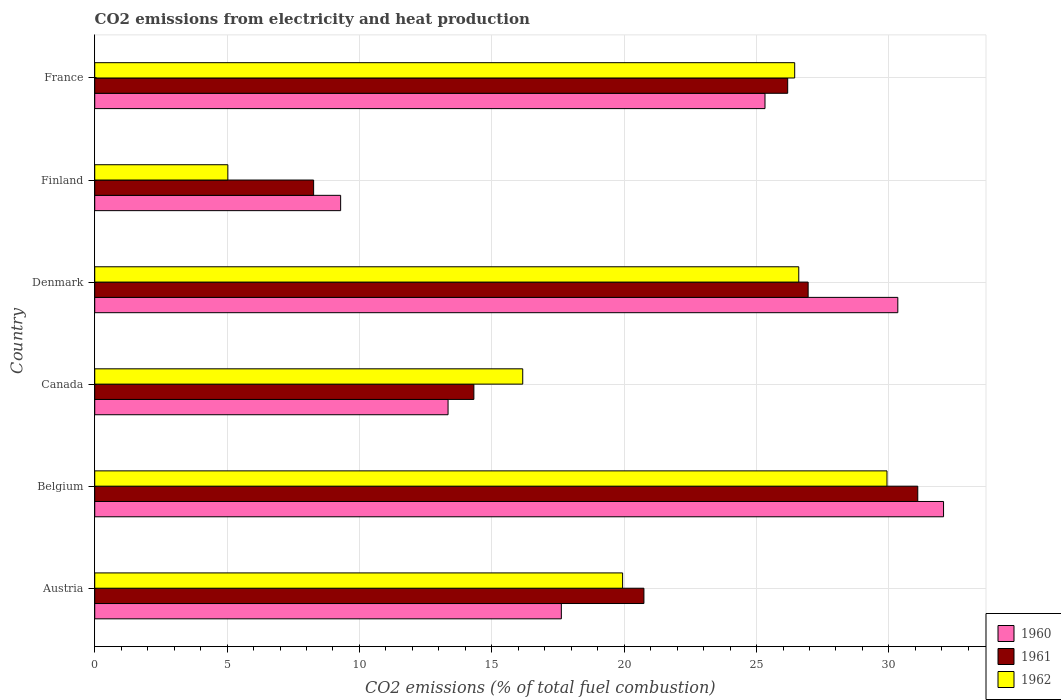How many different coloured bars are there?
Offer a very short reply. 3. What is the label of the 6th group of bars from the top?
Give a very brief answer. Austria. In how many cases, is the number of bars for a given country not equal to the number of legend labels?
Give a very brief answer. 0. What is the amount of CO2 emitted in 1961 in France?
Ensure brevity in your answer.  26.18. Across all countries, what is the maximum amount of CO2 emitted in 1961?
Provide a succinct answer. 31.09. Across all countries, what is the minimum amount of CO2 emitted in 1960?
Your answer should be compact. 9.29. In which country was the amount of CO2 emitted in 1960 maximum?
Give a very brief answer. Belgium. In which country was the amount of CO2 emitted in 1961 minimum?
Your answer should be very brief. Finland. What is the total amount of CO2 emitted in 1960 in the graph?
Offer a terse response. 127.98. What is the difference between the amount of CO2 emitted in 1962 in Denmark and that in Finland?
Keep it short and to the point. 21.57. What is the difference between the amount of CO2 emitted in 1961 in Finland and the amount of CO2 emitted in 1962 in Austria?
Offer a very short reply. -11.67. What is the average amount of CO2 emitted in 1961 per country?
Give a very brief answer. 21.26. What is the difference between the amount of CO2 emitted in 1962 and amount of CO2 emitted in 1960 in Canada?
Your response must be concise. 2.82. What is the ratio of the amount of CO2 emitted in 1960 in Canada to that in Finland?
Your answer should be very brief. 1.44. Is the amount of CO2 emitted in 1960 in Austria less than that in Canada?
Your answer should be compact. No. What is the difference between the highest and the second highest amount of CO2 emitted in 1960?
Make the answer very short. 1.73. What is the difference between the highest and the lowest amount of CO2 emitted in 1960?
Provide a succinct answer. 22.77. Is the sum of the amount of CO2 emitted in 1962 in Belgium and Canada greater than the maximum amount of CO2 emitted in 1961 across all countries?
Provide a succinct answer. Yes. What does the 3rd bar from the top in France represents?
Ensure brevity in your answer.  1960. What does the 1st bar from the bottom in Denmark represents?
Ensure brevity in your answer.  1960. Is it the case that in every country, the sum of the amount of CO2 emitted in 1962 and amount of CO2 emitted in 1961 is greater than the amount of CO2 emitted in 1960?
Offer a very short reply. Yes. How many bars are there?
Give a very brief answer. 18. Are all the bars in the graph horizontal?
Provide a short and direct response. Yes. What is the difference between two consecutive major ticks on the X-axis?
Ensure brevity in your answer.  5. Does the graph contain any zero values?
Keep it short and to the point. No. Does the graph contain grids?
Your answer should be very brief. Yes. What is the title of the graph?
Your response must be concise. CO2 emissions from electricity and heat production. Does "1971" appear as one of the legend labels in the graph?
Provide a succinct answer. No. What is the label or title of the X-axis?
Offer a very short reply. CO2 emissions (% of total fuel combustion). What is the label or title of the Y-axis?
Ensure brevity in your answer.  Country. What is the CO2 emissions (% of total fuel combustion) of 1960 in Austria?
Your answer should be compact. 17.63. What is the CO2 emissions (% of total fuel combustion) in 1961 in Austria?
Keep it short and to the point. 20.75. What is the CO2 emissions (% of total fuel combustion) in 1962 in Austria?
Provide a succinct answer. 19.94. What is the CO2 emissions (% of total fuel combustion) of 1960 in Belgium?
Give a very brief answer. 32.06. What is the CO2 emissions (% of total fuel combustion) of 1961 in Belgium?
Offer a terse response. 31.09. What is the CO2 emissions (% of total fuel combustion) in 1962 in Belgium?
Ensure brevity in your answer.  29.93. What is the CO2 emissions (% of total fuel combustion) in 1960 in Canada?
Ensure brevity in your answer.  13.35. What is the CO2 emissions (% of total fuel combustion) in 1961 in Canada?
Offer a very short reply. 14.32. What is the CO2 emissions (% of total fuel combustion) of 1962 in Canada?
Ensure brevity in your answer.  16.17. What is the CO2 emissions (% of total fuel combustion) in 1960 in Denmark?
Your response must be concise. 30.34. What is the CO2 emissions (% of total fuel combustion) in 1961 in Denmark?
Your answer should be very brief. 26.95. What is the CO2 emissions (% of total fuel combustion) in 1962 in Denmark?
Provide a short and direct response. 26.59. What is the CO2 emissions (% of total fuel combustion) of 1960 in Finland?
Offer a terse response. 9.29. What is the CO2 emissions (% of total fuel combustion) in 1961 in Finland?
Your response must be concise. 8.27. What is the CO2 emissions (% of total fuel combustion) in 1962 in Finland?
Ensure brevity in your answer.  5.03. What is the CO2 emissions (% of total fuel combustion) in 1960 in France?
Your answer should be compact. 25.32. What is the CO2 emissions (% of total fuel combustion) of 1961 in France?
Offer a terse response. 26.18. What is the CO2 emissions (% of total fuel combustion) of 1962 in France?
Keep it short and to the point. 26.44. Across all countries, what is the maximum CO2 emissions (% of total fuel combustion) in 1960?
Provide a short and direct response. 32.06. Across all countries, what is the maximum CO2 emissions (% of total fuel combustion) in 1961?
Offer a terse response. 31.09. Across all countries, what is the maximum CO2 emissions (% of total fuel combustion) in 1962?
Ensure brevity in your answer.  29.93. Across all countries, what is the minimum CO2 emissions (% of total fuel combustion) in 1960?
Offer a terse response. 9.29. Across all countries, what is the minimum CO2 emissions (% of total fuel combustion) of 1961?
Keep it short and to the point. 8.27. Across all countries, what is the minimum CO2 emissions (% of total fuel combustion) in 1962?
Make the answer very short. 5.03. What is the total CO2 emissions (% of total fuel combustion) in 1960 in the graph?
Your answer should be compact. 127.98. What is the total CO2 emissions (% of total fuel combustion) of 1961 in the graph?
Your answer should be very brief. 127.55. What is the total CO2 emissions (% of total fuel combustion) of 1962 in the graph?
Your answer should be compact. 124.1. What is the difference between the CO2 emissions (% of total fuel combustion) of 1960 in Austria and that in Belgium?
Your response must be concise. -14.44. What is the difference between the CO2 emissions (% of total fuel combustion) in 1961 in Austria and that in Belgium?
Your answer should be very brief. -10.34. What is the difference between the CO2 emissions (% of total fuel combustion) of 1962 in Austria and that in Belgium?
Keep it short and to the point. -9.99. What is the difference between the CO2 emissions (% of total fuel combustion) of 1960 in Austria and that in Canada?
Your response must be concise. 4.28. What is the difference between the CO2 emissions (% of total fuel combustion) of 1961 in Austria and that in Canada?
Make the answer very short. 6.42. What is the difference between the CO2 emissions (% of total fuel combustion) in 1962 in Austria and that in Canada?
Offer a very short reply. 3.77. What is the difference between the CO2 emissions (% of total fuel combustion) of 1960 in Austria and that in Denmark?
Keep it short and to the point. -12.71. What is the difference between the CO2 emissions (% of total fuel combustion) in 1961 in Austria and that in Denmark?
Your answer should be compact. -6.2. What is the difference between the CO2 emissions (% of total fuel combustion) in 1962 in Austria and that in Denmark?
Give a very brief answer. -6.65. What is the difference between the CO2 emissions (% of total fuel combustion) of 1960 in Austria and that in Finland?
Offer a terse response. 8.34. What is the difference between the CO2 emissions (% of total fuel combustion) in 1961 in Austria and that in Finland?
Ensure brevity in your answer.  12.48. What is the difference between the CO2 emissions (% of total fuel combustion) in 1962 in Austria and that in Finland?
Your answer should be very brief. 14.91. What is the difference between the CO2 emissions (% of total fuel combustion) in 1960 in Austria and that in France?
Give a very brief answer. -7.69. What is the difference between the CO2 emissions (% of total fuel combustion) in 1961 in Austria and that in France?
Keep it short and to the point. -5.43. What is the difference between the CO2 emissions (% of total fuel combustion) of 1962 in Austria and that in France?
Offer a very short reply. -6.5. What is the difference between the CO2 emissions (% of total fuel combustion) in 1960 in Belgium and that in Canada?
Keep it short and to the point. 18.72. What is the difference between the CO2 emissions (% of total fuel combustion) in 1961 in Belgium and that in Canada?
Provide a short and direct response. 16.77. What is the difference between the CO2 emissions (% of total fuel combustion) of 1962 in Belgium and that in Canada?
Your response must be concise. 13.76. What is the difference between the CO2 emissions (% of total fuel combustion) in 1960 in Belgium and that in Denmark?
Your answer should be compact. 1.73. What is the difference between the CO2 emissions (% of total fuel combustion) in 1961 in Belgium and that in Denmark?
Keep it short and to the point. 4.14. What is the difference between the CO2 emissions (% of total fuel combustion) of 1962 in Belgium and that in Denmark?
Your answer should be compact. 3.33. What is the difference between the CO2 emissions (% of total fuel combustion) of 1960 in Belgium and that in Finland?
Your answer should be compact. 22.77. What is the difference between the CO2 emissions (% of total fuel combustion) of 1961 in Belgium and that in Finland?
Make the answer very short. 22.82. What is the difference between the CO2 emissions (% of total fuel combustion) in 1962 in Belgium and that in Finland?
Provide a short and direct response. 24.9. What is the difference between the CO2 emissions (% of total fuel combustion) in 1960 in Belgium and that in France?
Offer a terse response. 6.74. What is the difference between the CO2 emissions (% of total fuel combustion) of 1961 in Belgium and that in France?
Offer a very short reply. 4.91. What is the difference between the CO2 emissions (% of total fuel combustion) in 1962 in Belgium and that in France?
Offer a very short reply. 3.49. What is the difference between the CO2 emissions (% of total fuel combustion) of 1960 in Canada and that in Denmark?
Give a very brief answer. -16.99. What is the difference between the CO2 emissions (% of total fuel combustion) of 1961 in Canada and that in Denmark?
Make the answer very short. -12.63. What is the difference between the CO2 emissions (% of total fuel combustion) in 1962 in Canada and that in Denmark?
Keep it short and to the point. -10.43. What is the difference between the CO2 emissions (% of total fuel combustion) in 1960 in Canada and that in Finland?
Make the answer very short. 4.06. What is the difference between the CO2 emissions (% of total fuel combustion) of 1961 in Canada and that in Finland?
Provide a succinct answer. 6.05. What is the difference between the CO2 emissions (% of total fuel combustion) in 1962 in Canada and that in Finland?
Offer a terse response. 11.14. What is the difference between the CO2 emissions (% of total fuel combustion) in 1960 in Canada and that in France?
Provide a short and direct response. -11.97. What is the difference between the CO2 emissions (% of total fuel combustion) of 1961 in Canada and that in France?
Offer a very short reply. -11.85. What is the difference between the CO2 emissions (% of total fuel combustion) of 1962 in Canada and that in France?
Offer a very short reply. -10.27. What is the difference between the CO2 emissions (% of total fuel combustion) in 1960 in Denmark and that in Finland?
Provide a short and direct response. 21.05. What is the difference between the CO2 emissions (% of total fuel combustion) in 1961 in Denmark and that in Finland?
Provide a succinct answer. 18.68. What is the difference between the CO2 emissions (% of total fuel combustion) of 1962 in Denmark and that in Finland?
Your response must be concise. 21.57. What is the difference between the CO2 emissions (% of total fuel combustion) in 1960 in Denmark and that in France?
Offer a very short reply. 5.02. What is the difference between the CO2 emissions (% of total fuel combustion) in 1961 in Denmark and that in France?
Keep it short and to the point. 0.77. What is the difference between the CO2 emissions (% of total fuel combustion) of 1962 in Denmark and that in France?
Keep it short and to the point. 0.15. What is the difference between the CO2 emissions (% of total fuel combustion) of 1960 in Finland and that in France?
Ensure brevity in your answer.  -16.03. What is the difference between the CO2 emissions (% of total fuel combustion) of 1961 in Finland and that in France?
Offer a very short reply. -17.91. What is the difference between the CO2 emissions (% of total fuel combustion) in 1962 in Finland and that in France?
Ensure brevity in your answer.  -21.41. What is the difference between the CO2 emissions (% of total fuel combustion) of 1960 in Austria and the CO2 emissions (% of total fuel combustion) of 1961 in Belgium?
Keep it short and to the point. -13.46. What is the difference between the CO2 emissions (% of total fuel combustion) of 1960 in Austria and the CO2 emissions (% of total fuel combustion) of 1962 in Belgium?
Provide a short and direct response. -12.3. What is the difference between the CO2 emissions (% of total fuel combustion) of 1961 in Austria and the CO2 emissions (% of total fuel combustion) of 1962 in Belgium?
Your response must be concise. -9.18. What is the difference between the CO2 emissions (% of total fuel combustion) of 1960 in Austria and the CO2 emissions (% of total fuel combustion) of 1961 in Canada?
Give a very brief answer. 3.3. What is the difference between the CO2 emissions (% of total fuel combustion) of 1960 in Austria and the CO2 emissions (% of total fuel combustion) of 1962 in Canada?
Your answer should be very brief. 1.46. What is the difference between the CO2 emissions (% of total fuel combustion) in 1961 in Austria and the CO2 emissions (% of total fuel combustion) in 1962 in Canada?
Give a very brief answer. 4.58. What is the difference between the CO2 emissions (% of total fuel combustion) of 1960 in Austria and the CO2 emissions (% of total fuel combustion) of 1961 in Denmark?
Your answer should be compact. -9.32. What is the difference between the CO2 emissions (% of total fuel combustion) of 1960 in Austria and the CO2 emissions (% of total fuel combustion) of 1962 in Denmark?
Your answer should be compact. -8.97. What is the difference between the CO2 emissions (% of total fuel combustion) in 1961 in Austria and the CO2 emissions (% of total fuel combustion) in 1962 in Denmark?
Make the answer very short. -5.85. What is the difference between the CO2 emissions (% of total fuel combustion) of 1960 in Austria and the CO2 emissions (% of total fuel combustion) of 1961 in Finland?
Offer a terse response. 9.36. What is the difference between the CO2 emissions (% of total fuel combustion) in 1960 in Austria and the CO2 emissions (% of total fuel combustion) in 1962 in Finland?
Offer a very short reply. 12.6. What is the difference between the CO2 emissions (% of total fuel combustion) in 1961 in Austria and the CO2 emissions (% of total fuel combustion) in 1962 in Finland?
Your response must be concise. 15.72. What is the difference between the CO2 emissions (% of total fuel combustion) in 1960 in Austria and the CO2 emissions (% of total fuel combustion) in 1961 in France?
Offer a very short reply. -8.55. What is the difference between the CO2 emissions (% of total fuel combustion) of 1960 in Austria and the CO2 emissions (% of total fuel combustion) of 1962 in France?
Your answer should be very brief. -8.81. What is the difference between the CO2 emissions (% of total fuel combustion) in 1961 in Austria and the CO2 emissions (% of total fuel combustion) in 1962 in France?
Make the answer very short. -5.69. What is the difference between the CO2 emissions (% of total fuel combustion) of 1960 in Belgium and the CO2 emissions (% of total fuel combustion) of 1961 in Canada?
Provide a succinct answer. 17.74. What is the difference between the CO2 emissions (% of total fuel combustion) in 1960 in Belgium and the CO2 emissions (% of total fuel combustion) in 1962 in Canada?
Provide a succinct answer. 15.9. What is the difference between the CO2 emissions (% of total fuel combustion) of 1961 in Belgium and the CO2 emissions (% of total fuel combustion) of 1962 in Canada?
Offer a terse response. 14.92. What is the difference between the CO2 emissions (% of total fuel combustion) in 1960 in Belgium and the CO2 emissions (% of total fuel combustion) in 1961 in Denmark?
Make the answer very short. 5.11. What is the difference between the CO2 emissions (% of total fuel combustion) of 1960 in Belgium and the CO2 emissions (% of total fuel combustion) of 1962 in Denmark?
Your response must be concise. 5.47. What is the difference between the CO2 emissions (% of total fuel combustion) of 1961 in Belgium and the CO2 emissions (% of total fuel combustion) of 1962 in Denmark?
Keep it short and to the point. 4.5. What is the difference between the CO2 emissions (% of total fuel combustion) in 1960 in Belgium and the CO2 emissions (% of total fuel combustion) in 1961 in Finland?
Keep it short and to the point. 23.79. What is the difference between the CO2 emissions (% of total fuel combustion) in 1960 in Belgium and the CO2 emissions (% of total fuel combustion) in 1962 in Finland?
Your answer should be compact. 27.04. What is the difference between the CO2 emissions (% of total fuel combustion) in 1961 in Belgium and the CO2 emissions (% of total fuel combustion) in 1962 in Finland?
Your answer should be compact. 26.06. What is the difference between the CO2 emissions (% of total fuel combustion) in 1960 in Belgium and the CO2 emissions (% of total fuel combustion) in 1961 in France?
Offer a very short reply. 5.89. What is the difference between the CO2 emissions (% of total fuel combustion) in 1960 in Belgium and the CO2 emissions (% of total fuel combustion) in 1962 in France?
Offer a terse response. 5.62. What is the difference between the CO2 emissions (% of total fuel combustion) of 1961 in Belgium and the CO2 emissions (% of total fuel combustion) of 1962 in France?
Offer a terse response. 4.65. What is the difference between the CO2 emissions (% of total fuel combustion) of 1960 in Canada and the CO2 emissions (% of total fuel combustion) of 1961 in Denmark?
Provide a succinct answer. -13.6. What is the difference between the CO2 emissions (% of total fuel combustion) in 1960 in Canada and the CO2 emissions (% of total fuel combustion) in 1962 in Denmark?
Offer a terse response. -13.25. What is the difference between the CO2 emissions (% of total fuel combustion) in 1961 in Canada and the CO2 emissions (% of total fuel combustion) in 1962 in Denmark?
Offer a very short reply. -12.27. What is the difference between the CO2 emissions (% of total fuel combustion) in 1960 in Canada and the CO2 emissions (% of total fuel combustion) in 1961 in Finland?
Offer a terse response. 5.08. What is the difference between the CO2 emissions (% of total fuel combustion) of 1960 in Canada and the CO2 emissions (% of total fuel combustion) of 1962 in Finland?
Your answer should be very brief. 8.32. What is the difference between the CO2 emissions (% of total fuel combustion) in 1961 in Canada and the CO2 emissions (% of total fuel combustion) in 1962 in Finland?
Your response must be concise. 9.29. What is the difference between the CO2 emissions (% of total fuel combustion) in 1960 in Canada and the CO2 emissions (% of total fuel combustion) in 1961 in France?
Provide a succinct answer. -12.83. What is the difference between the CO2 emissions (% of total fuel combustion) in 1960 in Canada and the CO2 emissions (% of total fuel combustion) in 1962 in France?
Keep it short and to the point. -13.09. What is the difference between the CO2 emissions (% of total fuel combustion) in 1961 in Canada and the CO2 emissions (% of total fuel combustion) in 1962 in France?
Offer a very short reply. -12.12. What is the difference between the CO2 emissions (% of total fuel combustion) in 1960 in Denmark and the CO2 emissions (% of total fuel combustion) in 1961 in Finland?
Make the answer very short. 22.07. What is the difference between the CO2 emissions (% of total fuel combustion) in 1960 in Denmark and the CO2 emissions (% of total fuel combustion) in 1962 in Finland?
Your answer should be very brief. 25.31. What is the difference between the CO2 emissions (% of total fuel combustion) in 1961 in Denmark and the CO2 emissions (% of total fuel combustion) in 1962 in Finland?
Ensure brevity in your answer.  21.92. What is the difference between the CO2 emissions (% of total fuel combustion) in 1960 in Denmark and the CO2 emissions (% of total fuel combustion) in 1961 in France?
Offer a terse response. 4.16. What is the difference between the CO2 emissions (% of total fuel combustion) in 1960 in Denmark and the CO2 emissions (% of total fuel combustion) in 1962 in France?
Provide a succinct answer. 3.9. What is the difference between the CO2 emissions (% of total fuel combustion) of 1961 in Denmark and the CO2 emissions (% of total fuel combustion) of 1962 in France?
Your answer should be compact. 0.51. What is the difference between the CO2 emissions (% of total fuel combustion) in 1960 in Finland and the CO2 emissions (% of total fuel combustion) in 1961 in France?
Provide a short and direct response. -16.89. What is the difference between the CO2 emissions (% of total fuel combustion) of 1960 in Finland and the CO2 emissions (% of total fuel combustion) of 1962 in France?
Ensure brevity in your answer.  -17.15. What is the difference between the CO2 emissions (% of total fuel combustion) of 1961 in Finland and the CO2 emissions (% of total fuel combustion) of 1962 in France?
Give a very brief answer. -18.17. What is the average CO2 emissions (% of total fuel combustion) of 1960 per country?
Offer a very short reply. 21.33. What is the average CO2 emissions (% of total fuel combustion) in 1961 per country?
Ensure brevity in your answer.  21.26. What is the average CO2 emissions (% of total fuel combustion) in 1962 per country?
Offer a terse response. 20.68. What is the difference between the CO2 emissions (% of total fuel combustion) of 1960 and CO2 emissions (% of total fuel combustion) of 1961 in Austria?
Your answer should be compact. -3.12. What is the difference between the CO2 emissions (% of total fuel combustion) in 1960 and CO2 emissions (% of total fuel combustion) in 1962 in Austria?
Make the answer very short. -2.31. What is the difference between the CO2 emissions (% of total fuel combustion) in 1961 and CO2 emissions (% of total fuel combustion) in 1962 in Austria?
Ensure brevity in your answer.  0.81. What is the difference between the CO2 emissions (% of total fuel combustion) of 1960 and CO2 emissions (% of total fuel combustion) of 1962 in Belgium?
Your answer should be compact. 2.14. What is the difference between the CO2 emissions (% of total fuel combustion) of 1961 and CO2 emissions (% of total fuel combustion) of 1962 in Belgium?
Ensure brevity in your answer.  1.16. What is the difference between the CO2 emissions (% of total fuel combustion) in 1960 and CO2 emissions (% of total fuel combustion) in 1961 in Canada?
Offer a very short reply. -0.98. What is the difference between the CO2 emissions (% of total fuel combustion) of 1960 and CO2 emissions (% of total fuel combustion) of 1962 in Canada?
Offer a very short reply. -2.82. What is the difference between the CO2 emissions (% of total fuel combustion) of 1961 and CO2 emissions (% of total fuel combustion) of 1962 in Canada?
Provide a short and direct response. -1.85. What is the difference between the CO2 emissions (% of total fuel combustion) in 1960 and CO2 emissions (% of total fuel combustion) in 1961 in Denmark?
Ensure brevity in your answer.  3.39. What is the difference between the CO2 emissions (% of total fuel combustion) of 1960 and CO2 emissions (% of total fuel combustion) of 1962 in Denmark?
Your response must be concise. 3.74. What is the difference between the CO2 emissions (% of total fuel combustion) in 1961 and CO2 emissions (% of total fuel combustion) in 1962 in Denmark?
Your response must be concise. 0.35. What is the difference between the CO2 emissions (% of total fuel combustion) in 1960 and CO2 emissions (% of total fuel combustion) in 1961 in Finland?
Your answer should be very brief. 1.02. What is the difference between the CO2 emissions (% of total fuel combustion) in 1960 and CO2 emissions (% of total fuel combustion) in 1962 in Finland?
Provide a short and direct response. 4.26. What is the difference between the CO2 emissions (% of total fuel combustion) of 1961 and CO2 emissions (% of total fuel combustion) of 1962 in Finland?
Make the answer very short. 3.24. What is the difference between the CO2 emissions (% of total fuel combustion) in 1960 and CO2 emissions (% of total fuel combustion) in 1961 in France?
Give a very brief answer. -0.86. What is the difference between the CO2 emissions (% of total fuel combustion) in 1960 and CO2 emissions (% of total fuel combustion) in 1962 in France?
Make the answer very short. -1.12. What is the difference between the CO2 emissions (% of total fuel combustion) of 1961 and CO2 emissions (% of total fuel combustion) of 1962 in France?
Give a very brief answer. -0.26. What is the ratio of the CO2 emissions (% of total fuel combustion) of 1960 in Austria to that in Belgium?
Offer a terse response. 0.55. What is the ratio of the CO2 emissions (% of total fuel combustion) in 1961 in Austria to that in Belgium?
Give a very brief answer. 0.67. What is the ratio of the CO2 emissions (% of total fuel combustion) in 1962 in Austria to that in Belgium?
Provide a short and direct response. 0.67. What is the ratio of the CO2 emissions (% of total fuel combustion) of 1960 in Austria to that in Canada?
Provide a succinct answer. 1.32. What is the ratio of the CO2 emissions (% of total fuel combustion) in 1961 in Austria to that in Canada?
Offer a very short reply. 1.45. What is the ratio of the CO2 emissions (% of total fuel combustion) of 1962 in Austria to that in Canada?
Offer a very short reply. 1.23. What is the ratio of the CO2 emissions (% of total fuel combustion) in 1960 in Austria to that in Denmark?
Offer a terse response. 0.58. What is the ratio of the CO2 emissions (% of total fuel combustion) in 1961 in Austria to that in Denmark?
Your answer should be very brief. 0.77. What is the ratio of the CO2 emissions (% of total fuel combustion) of 1962 in Austria to that in Denmark?
Ensure brevity in your answer.  0.75. What is the ratio of the CO2 emissions (% of total fuel combustion) in 1960 in Austria to that in Finland?
Make the answer very short. 1.9. What is the ratio of the CO2 emissions (% of total fuel combustion) of 1961 in Austria to that in Finland?
Keep it short and to the point. 2.51. What is the ratio of the CO2 emissions (% of total fuel combustion) in 1962 in Austria to that in Finland?
Offer a terse response. 3.97. What is the ratio of the CO2 emissions (% of total fuel combustion) of 1960 in Austria to that in France?
Your response must be concise. 0.7. What is the ratio of the CO2 emissions (% of total fuel combustion) of 1961 in Austria to that in France?
Your answer should be compact. 0.79. What is the ratio of the CO2 emissions (% of total fuel combustion) of 1962 in Austria to that in France?
Give a very brief answer. 0.75. What is the ratio of the CO2 emissions (% of total fuel combustion) of 1960 in Belgium to that in Canada?
Provide a short and direct response. 2.4. What is the ratio of the CO2 emissions (% of total fuel combustion) in 1961 in Belgium to that in Canada?
Provide a succinct answer. 2.17. What is the ratio of the CO2 emissions (% of total fuel combustion) of 1962 in Belgium to that in Canada?
Offer a terse response. 1.85. What is the ratio of the CO2 emissions (% of total fuel combustion) of 1960 in Belgium to that in Denmark?
Give a very brief answer. 1.06. What is the ratio of the CO2 emissions (% of total fuel combustion) of 1961 in Belgium to that in Denmark?
Your answer should be compact. 1.15. What is the ratio of the CO2 emissions (% of total fuel combustion) of 1962 in Belgium to that in Denmark?
Offer a very short reply. 1.13. What is the ratio of the CO2 emissions (% of total fuel combustion) of 1960 in Belgium to that in Finland?
Your answer should be very brief. 3.45. What is the ratio of the CO2 emissions (% of total fuel combustion) in 1961 in Belgium to that in Finland?
Provide a succinct answer. 3.76. What is the ratio of the CO2 emissions (% of total fuel combustion) in 1962 in Belgium to that in Finland?
Offer a terse response. 5.95. What is the ratio of the CO2 emissions (% of total fuel combustion) in 1960 in Belgium to that in France?
Keep it short and to the point. 1.27. What is the ratio of the CO2 emissions (% of total fuel combustion) in 1961 in Belgium to that in France?
Your answer should be very brief. 1.19. What is the ratio of the CO2 emissions (% of total fuel combustion) in 1962 in Belgium to that in France?
Your answer should be compact. 1.13. What is the ratio of the CO2 emissions (% of total fuel combustion) of 1960 in Canada to that in Denmark?
Keep it short and to the point. 0.44. What is the ratio of the CO2 emissions (% of total fuel combustion) of 1961 in Canada to that in Denmark?
Offer a very short reply. 0.53. What is the ratio of the CO2 emissions (% of total fuel combustion) of 1962 in Canada to that in Denmark?
Your response must be concise. 0.61. What is the ratio of the CO2 emissions (% of total fuel combustion) in 1960 in Canada to that in Finland?
Your answer should be very brief. 1.44. What is the ratio of the CO2 emissions (% of total fuel combustion) in 1961 in Canada to that in Finland?
Make the answer very short. 1.73. What is the ratio of the CO2 emissions (% of total fuel combustion) of 1962 in Canada to that in Finland?
Ensure brevity in your answer.  3.22. What is the ratio of the CO2 emissions (% of total fuel combustion) of 1960 in Canada to that in France?
Give a very brief answer. 0.53. What is the ratio of the CO2 emissions (% of total fuel combustion) in 1961 in Canada to that in France?
Give a very brief answer. 0.55. What is the ratio of the CO2 emissions (% of total fuel combustion) of 1962 in Canada to that in France?
Your answer should be compact. 0.61. What is the ratio of the CO2 emissions (% of total fuel combustion) of 1960 in Denmark to that in Finland?
Keep it short and to the point. 3.27. What is the ratio of the CO2 emissions (% of total fuel combustion) in 1961 in Denmark to that in Finland?
Keep it short and to the point. 3.26. What is the ratio of the CO2 emissions (% of total fuel combustion) in 1962 in Denmark to that in Finland?
Provide a short and direct response. 5.29. What is the ratio of the CO2 emissions (% of total fuel combustion) in 1960 in Denmark to that in France?
Your answer should be very brief. 1.2. What is the ratio of the CO2 emissions (% of total fuel combustion) of 1961 in Denmark to that in France?
Ensure brevity in your answer.  1.03. What is the ratio of the CO2 emissions (% of total fuel combustion) in 1962 in Denmark to that in France?
Make the answer very short. 1.01. What is the ratio of the CO2 emissions (% of total fuel combustion) in 1960 in Finland to that in France?
Provide a short and direct response. 0.37. What is the ratio of the CO2 emissions (% of total fuel combustion) in 1961 in Finland to that in France?
Ensure brevity in your answer.  0.32. What is the ratio of the CO2 emissions (% of total fuel combustion) in 1962 in Finland to that in France?
Keep it short and to the point. 0.19. What is the difference between the highest and the second highest CO2 emissions (% of total fuel combustion) of 1960?
Your answer should be compact. 1.73. What is the difference between the highest and the second highest CO2 emissions (% of total fuel combustion) of 1961?
Offer a very short reply. 4.14. What is the difference between the highest and the second highest CO2 emissions (% of total fuel combustion) in 1962?
Make the answer very short. 3.33. What is the difference between the highest and the lowest CO2 emissions (% of total fuel combustion) of 1960?
Ensure brevity in your answer.  22.77. What is the difference between the highest and the lowest CO2 emissions (% of total fuel combustion) of 1961?
Provide a succinct answer. 22.82. What is the difference between the highest and the lowest CO2 emissions (% of total fuel combustion) of 1962?
Give a very brief answer. 24.9. 